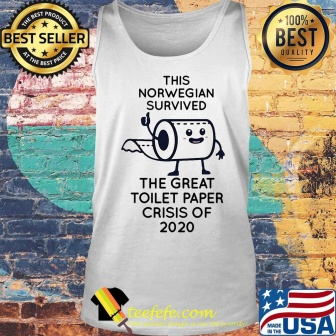Can you provide a brief overview of what this image represents? The image represents a humorous product, specifically a white tank top featuring a cartoon toilet paper roll. It commemorates surviving the toilet paper shortages of 2020 during the early days of the COVID-19 pandemic, with a humorous text. The tank top is showcased as a best-selling, high-quality item against a rustic brick wall backdrop, with an American flag adding to the theme. 